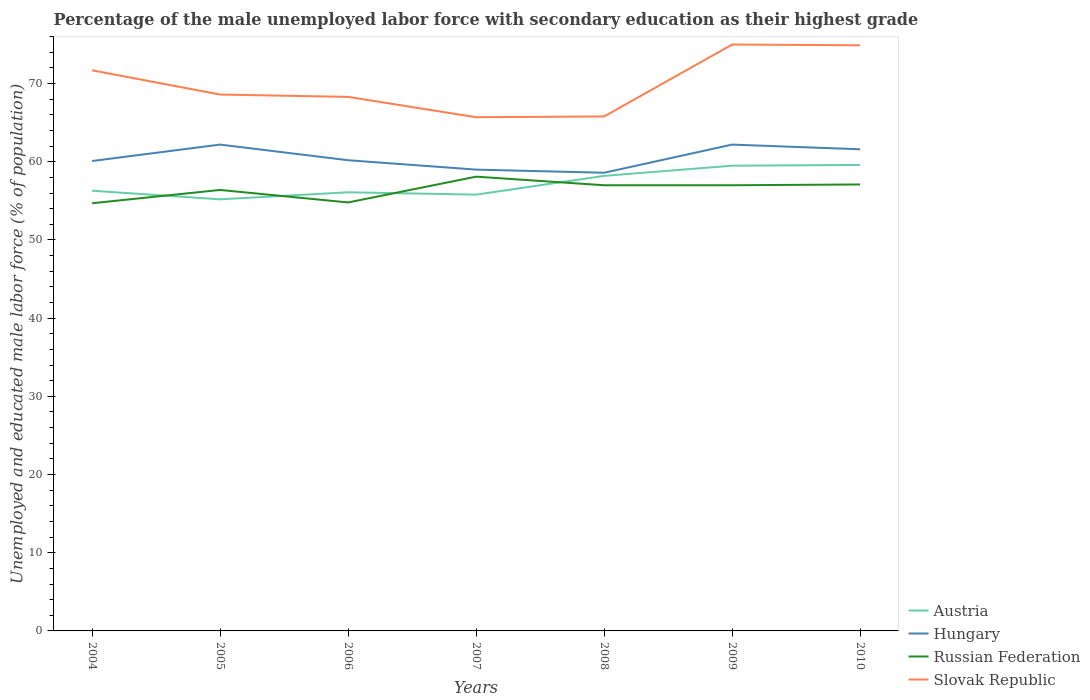Is the number of lines equal to the number of legend labels?
Give a very brief answer. Yes. Across all years, what is the maximum percentage of the unemployed male labor force with secondary education in Russian Federation?
Offer a terse response. 54.7. In which year was the percentage of the unemployed male labor force with secondary education in Hungary maximum?
Your answer should be compact. 2008. What is the total percentage of the unemployed male labor force with secondary education in Russian Federation in the graph?
Provide a succinct answer. -2.3. What is the difference between the highest and the second highest percentage of the unemployed male labor force with secondary education in Hungary?
Keep it short and to the point. 3.6. What is the difference between the highest and the lowest percentage of the unemployed male labor force with secondary education in Hungary?
Make the answer very short. 3. Is the percentage of the unemployed male labor force with secondary education in Slovak Republic strictly greater than the percentage of the unemployed male labor force with secondary education in Russian Federation over the years?
Your answer should be very brief. No. What is the difference between two consecutive major ticks on the Y-axis?
Make the answer very short. 10. Are the values on the major ticks of Y-axis written in scientific E-notation?
Ensure brevity in your answer.  No. Does the graph contain grids?
Give a very brief answer. No. How many legend labels are there?
Give a very brief answer. 4. What is the title of the graph?
Your response must be concise. Percentage of the male unemployed labor force with secondary education as their highest grade. What is the label or title of the Y-axis?
Make the answer very short. Unemployed and educated male labor force (% of population). What is the Unemployed and educated male labor force (% of population) of Austria in 2004?
Provide a short and direct response. 56.3. What is the Unemployed and educated male labor force (% of population) of Hungary in 2004?
Ensure brevity in your answer.  60.1. What is the Unemployed and educated male labor force (% of population) in Russian Federation in 2004?
Your answer should be compact. 54.7. What is the Unemployed and educated male labor force (% of population) of Slovak Republic in 2004?
Offer a very short reply. 71.7. What is the Unemployed and educated male labor force (% of population) of Austria in 2005?
Give a very brief answer. 55.2. What is the Unemployed and educated male labor force (% of population) of Hungary in 2005?
Offer a very short reply. 62.2. What is the Unemployed and educated male labor force (% of population) in Russian Federation in 2005?
Make the answer very short. 56.4. What is the Unemployed and educated male labor force (% of population) in Slovak Republic in 2005?
Give a very brief answer. 68.6. What is the Unemployed and educated male labor force (% of population) of Austria in 2006?
Offer a very short reply. 56.1. What is the Unemployed and educated male labor force (% of population) in Hungary in 2006?
Offer a very short reply. 60.2. What is the Unemployed and educated male labor force (% of population) in Russian Federation in 2006?
Your answer should be very brief. 54.8. What is the Unemployed and educated male labor force (% of population) in Slovak Republic in 2006?
Provide a short and direct response. 68.3. What is the Unemployed and educated male labor force (% of population) of Austria in 2007?
Provide a succinct answer. 55.8. What is the Unemployed and educated male labor force (% of population) in Hungary in 2007?
Make the answer very short. 59. What is the Unemployed and educated male labor force (% of population) in Russian Federation in 2007?
Offer a terse response. 58.1. What is the Unemployed and educated male labor force (% of population) in Slovak Republic in 2007?
Provide a short and direct response. 65.7. What is the Unemployed and educated male labor force (% of population) in Austria in 2008?
Your response must be concise. 58.2. What is the Unemployed and educated male labor force (% of population) of Hungary in 2008?
Provide a short and direct response. 58.6. What is the Unemployed and educated male labor force (% of population) of Russian Federation in 2008?
Ensure brevity in your answer.  57. What is the Unemployed and educated male labor force (% of population) in Slovak Republic in 2008?
Your response must be concise. 65.8. What is the Unemployed and educated male labor force (% of population) of Austria in 2009?
Offer a very short reply. 59.5. What is the Unemployed and educated male labor force (% of population) in Hungary in 2009?
Keep it short and to the point. 62.2. What is the Unemployed and educated male labor force (% of population) of Russian Federation in 2009?
Provide a short and direct response. 57. What is the Unemployed and educated male labor force (% of population) in Austria in 2010?
Make the answer very short. 59.6. What is the Unemployed and educated male labor force (% of population) of Hungary in 2010?
Your answer should be compact. 61.6. What is the Unemployed and educated male labor force (% of population) of Russian Federation in 2010?
Offer a very short reply. 57.1. What is the Unemployed and educated male labor force (% of population) of Slovak Republic in 2010?
Provide a succinct answer. 74.9. Across all years, what is the maximum Unemployed and educated male labor force (% of population) of Austria?
Your answer should be very brief. 59.6. Across all years, what is the maximum Unemployed and educated male labor force (% of population) in Hungary?
Give a very brief answer. 62.2. Across all years, what is the maximum Unemployed and educated male labor force (% of population) of Russian Federation?
Your answer should be very brief. 58.1. Across all years, what is the maximum Unemployed and educated male labor force (% of population) in Slovak Republic?
Make the answer very short. 75. Across all years, what is the minimum Unemployed and educated male labor force (% of population) in Austria?
Your response must be concise. 55.2. Across all years, what is the minimum Unemployed and educated male labor force (% of population) of Hungary?
Offer a very short reply. 58.6. Across all years, what is the minimum Unemployed and educated male labor force (% of population) in Russian Federation?
Keep it short and to the point. 54.7. Across all years, what is the minimum Unemployed and educated male labor force (% of population) of Slovak Republic?
Make the answer very short. 65.7. What is the total Unemployed and educated male labor force (% of population) of Austria in the graph?
Offer a very short reply. 400.7. What is the total Unemployed and educated male labor force (% of population) in Hungary in the graph?
Your answer should be very brief. 423.9. What is the total Unemployed and educated male labor force (% of population) of Russian Federation in the graph?
Provide a succinct answer. 395.1. What is the total Unemployed and educated male labor force (% of population) of Slovak Republic in the graph?
Offer a very short reply. 490. What is the difference between the Unemployed and educated male labor force (% of population) in Austria in 2004 and that in 2005?
Offer a terse response. 1.1. What is the difference between the Unemployed and educated male labor force (% of population) in Russian Federation in 2004 and that in 2005?
Your response must be concise. -1.7. What is the difference between the Unemployed and educated male labor force (% of population) in Russian Federation in 2004 and that in 2006?
Keep it short and to the point. -0.1. What is the difference between the Unemployed and educated male labor force (% of population) in Austria in 2004 and that in 2007?
Ensure brevity in your answer.  0.5. What is the difference between the Unemployed and educated male labor force (% of population) in Hungary in 2004 and that in 2007?
Keep it short and to the point. 1.1. What is the difference between the Unemployed and educated male labor force (% of population) in Russian Federation in 2004 and that in 2007?
Give a very brief answer. -3.4. What is the difference between the Unemployed and educated male labor force (% of population) in Slovak Republic in 2004 and that in 2007?
Provide a succinct answer. 6. What is the difference between the Unemployed and educated male labor force (% of population) in Slovak Republic in 2004 and that in 2008?
Offer a terse response. 5.9. What is the difference between the Unemployed and educated male labor force (% of population) in Austria in 2004 and that in 2009?
Keep it short and to the point. -3.2. What is the difference between the Unemployed and educated male labor force (% of population) in Hungary in 2004 and that in 2009?
Offer a terse response. -2.1. What is the difference between the Unemployed and educated male labor force (% of population) of Slovak Republic in 2004 and that in 2009?
Your answer should be very brief. -3.3. What is the difference between the Unemployed and educated male labor force (% of population) in Austria in 2004 and that in 2010?
Make the answer very short. -3.3. What is the difference between the Unemployed and educated male labor force (% of population) in Hungary in 2004 and that in 2010?
Provide a short and direct response. -1.5. What is the difference between the Unemployed and educated male labor force (% of population) of Russian Federation in 2004 and that in 2010?
Ensure brevity in your answer.  -2.4. What is the difference between the Unemployed and educated male labor force (% of population) in Slovak Republic in 2004 and that in 2010?
Ensure brevity in your answer.  -3.2. What is the difference between the Unemployed and educated male labor force (% of population) in Hungary in 2005 and that in 2006?
Your answer should be very brief. 2. What is the difference between the Unemployed and educated male labor force (% of population) in Slovak Republic in 2005 and that in 2006?
Give a very brief answer. 0.3. What is the difference between the Unemployed and educated male labor force (% of population) in Hungary in 2005 and that in 2007?
Your response must be concise. 3.2. What is the difference between the Unemployed and educated male labor force (% of population) of Russian Federation in 2005 and that in 2007?
Ensure brevity in your answer.  -1.7. What is the difference between the Unemployed and educated male labor force (% of population) in Slovak Republic in 2005 and that in 2007?
Provide a succinct answer. 2.9. What is the difference between the Unemployed and educated male labor force (% of population) of Russian Federation in 2005 and that in 2008?
Keep it short and to the point. -0.6. What is the difference between the Unemployed and educated male labor force (% of population) in Slovak Republic in 2005 and that in 2008?
Your answer should be very brief. 2.8. What is the difference between the Unemployed and educated male labor force (% of population) in Russian Federation in 2005 and that in 2009?
Offer a very short reply. -0.6. What is the difference between the Unemployed and educated male labor force (% of population) in Austria in 2005 and that in 2010?
Your answer should be very brief. -4.4. What is the difference between the Unemployed and educated male labor force (% of population) in Hungary in 2005 and that in 2010?
Provide a short and direct response. 0.6. What is the difference between the Unemployed and educated male labor force (% of population) of Slovak Republic in 2005 and that in 2010?
Give a very brief answer. -6.3. What is the difference between the Unemployed and educated male labor force (% of population) in Hungary in 2006 and that in 2007?
Your response must be concise. 1.2. What is the difference between the Unemployed and educated male labor force (% of population) in Slovak Republic in 2006 and that in 2007?
Ensure brevity in your answer.  2.6. What is the difference between the Unemployed and educated male labor force (% of population) of Hungary in 2006 and that in 2008?
Your response must be concise. 1.6. What is the difference between the Unemployed and educated male labor force (% of population) of Austria in 2006 and that in 2009?
Ensure brevity in your answer.  -3.4. What is the difference between the Unemployed and educated male labor force (% of population) of Russian Federation in 2006 and that in 2009?
Your answer should be compact. -2.2. What is the difference between the Unemployed and educated male labor force (% of population) of Slovak Republic in 2006 and that in 2009?
Make the answer very short. -6.7. What is the difference between the Unemployed and educated male labor force (% of population) in Slovak Republic in 2006 and that in 2010?
Offer a terse response. -6.6. What is the difference between the Unemployed and educated male labor force (% of population) in Austria in 2007 and that in 2008?
Offer a very short reply. -2.4. What is the difference between the Unemployed and educated male labor force (% of population) in Hungary in 2007 and that in 2008?
Offer a terse response. 0.4. What is the difference between the Unemployed and educated male labor force (% of population) in Slovak Republic in 2007 and that in 2008?
Provide a short and direct response. -0.1. What is the difference between the Unemployed and educated male labor force (% of population) of Austria in 2007 and that in 2009?
Make the answer very short. -3.7. What is the difference between the Unemployed and educated male labor force (% of population) of Hungary in 2007 and that in 2009?
Your answer should be very brief. -3.2. What is the difference between the Unemployed and educated male labor force (% of population) in Slovak Republic in 2007 and that in 2009?
Give a very brief answer. -9.3. What is the difference between the Unemployed and educated male labor force (% of population) of Russian Federation in 2007 and that in 2010?
Provide a short and direct response. 1. What is the difference between the Unemployed and educated male labor force (% of population) in Slovak Republic in 2007 and that in 2010?
Your response must be concise. -9.2. What is the difference between the Unemployed and educated male labor force (% of population) of Austria in 2008 and that in 2009?
Your response must be concise. -1.3. What is the difference between the Unemployed and educated male labor force (% of population) of Hungary in 2008 and that in 2009?
Make the answer very short. -3.6. What is the difference between the Unemployed and educated male labor force (% of population) in Austria in 2008 and that in 2010?
Your response must be concise. -1.4. What is the difference between the Unemployed and educated male labor force (% of population) of Russian Federation in 2008 and that in 2010?
Your answer should be very brief. -0.1. What is the difference between the Unemployed and educated male labor force (% of population) of Austria in 2009 and that in 2010?
Provide a short and direct response. -0.1. What is the difference between the Unemployed and educated male labor force (% of population) of Hungary in 2009 and that in 2010?
Ensure brevity in your answer.  0.6. What is the difference between the Unemployed and educated male labor force (% of population) in Slovak Republic in 2009 and that in 2010?
Keep it short and to the point. 0.1. What is the difference between the Unemployed and educated male labor force (% of population) of Hungary in 2004 and the Unemployed and educated male labor force (% of population) of Slovak Republic in 2005?
Offer a very short reply. -8.5. What is the difference between the Unemployed and educated male labor force (% of population) in Russian Federation in 2004 and the Unemployed and educated male labor force (% of population) in Slovak Republic in 2005?
Your answer should be very brief. -13.9. What is the difference between the Unemployed and educated male labor force (% of population) of Austria in 2004 and the Unemployed and educated male labor force (% of population) of Russian Federation in 2006?
Your answer should be very brief. 1.5. What is the difference between the Unemployed and educated male labor force (% of population) in Austria in 2004 and the Unemployed and educated male labor force (% of population) in Slovak Republic in 2006?
Make the answer very short. -12. What is the difference between the Unemployed and educated male labor force (% of population) of Hungary in 2004 and the Unemployed and educated male labor force (% of population) of Russian Federation in 2006?
Your answer should be very brief. 5.3. What is the difference between the Unemployed and educated male labor force (% of population) in Hungary in 2004 and the Unemployed and educated male labor force (% of population) in Slovak Republic in 2006?
Offer a very short reply. -8.2. What is the difference between the Unemployed and educated male labor force (% of population) of Austria in 2004 and the Unemployed and educated male labor force (% of population) of Hungary in 2007?
Your answer should be very brief. -2.7. What is the difference between the Unemployed and educated male labor force (% of population) in Austria in 2004 and the Unemployed and educated male labor force (% of population) in Russian Federation in 2007?
Offer a very short reply. -1.8. What is the difference between the Unemployed and educated male labor force (% of population) in Hungary in 2004 and the Unemployed and educated male labor force (% of population) in Slovak Republic in 2007?
Provide a short and direct response. -5.6. What is the difference between the Unemployed and educated male labor force (% of population) in Russian Federation in 2004 and the Unemployed and educated male labor force (% of population) in Slovak Republic in 2007?
Your response must be concise. -11. What is the difference between the Unemployed and educated male labor force (% of population) of Hungary in 2004 and the Unemployed and educated male labor force (% of population) of Russian Federation in 2008?
Ensure brevity in your answer.  3.1. What is the difference between the Unemployed and educated male labor force (% of population) in Hungary in 2004 and the Unemployed and educated male labor force (% of population) in Slovak Republic in 2008?
Keep it short and to the point. -5.7. What is the difference between the Unemployed and educated male labor force (% of population) of Austria in 2004 and the Unemployed and educated male labor force (% of population) of Russian Federation in 2009?
Offer a terse response. -0.7. What is the difference between the Unemployed and educated male labor force (% of population) of Austria in 2004 and the Unemployed and educated male labor force (% of population) of Slovak Republic in 2009?
Provide a succinct answer. -18.7. What is the difference between the Unemployed and educated male labor force (% of population) of Hungary in 2004 and the Unemployed and educated male labor force (% of population) of Russian Federation in 2009?
Keep it short and to the point. 3.1. What is the difference between the Unemployed and educated male labor force (% of population) of Hungary in 2004 and the Unemployed and educated male labor force (% of population) of Slovak Republic in 2009?
Keep it short and to the point. -14.9. What is the difference between the Unemployed and educated male labor force (% of population) in Russian Federation in 2004 and the Unemployed and educated male labor force (% of population) in Slovak Republic in 2009?
Your answer should be compact. -20.3. What is the difference between the Unemployed and educated male labor force (% of population) in Austria in 2004 and the Unemployed and educated male labor force (% of population) in Russian Federation in 2010?
Your response must be concise. -0.8. What is the difference between the Unemployed and educated male labor force (% of population) of Austria in 2004 and the Unemployed and educated male labor force (% of population) of Slovak Republic in 2010?
Keep it short and to the point. -18.6. What is the difference between the Unemployed and educated male labor force (% of population) of Hungary in 2004 and the Unemployed and educated male labor force (% of population) of Russian Federation in 2010?
Provide a succinct answer. 3. What is the difference between the Unemployed and educated male labor force (% of population) in Hungary in 2004 and the Unemployed and educated male labor force (% of population) in Slovak Republic in 2010?
Keep it short and to the point. -14.8. What is the difference between the Unemployed and educated male labor force (% of population) in Russian Federation in 2004 and the Unemployed and educated male labor force (% of population) in Slovak Republic in 2010?
Your response must be concise. -20.2. What is the difference between the Unemployed and educated male labor force (% of population) in Austria in 2005 and the Unemployed and educated male labor force (% of population) in Russian Federation in 2006?
Give a very brief answer. 0.4. What is the difference between the Unemployed and educated male labor force (% of population) of Austria in 2005 and the Unemployed and educated male labor force (% of population) of Slovak Republic in 2006?
Offer a very short reply. -13.1. What is the difference between the Unemployed and educated male labor force (% of population) in Hungary in 2005 and the Unemployed and educated male labor force (% of population) in Russian Federation in 2006?
Provide a succinct answer. 7.4. What is the difference between the Unemployed and educated male labor force (% of population) of Russian Federation in 2005 and the Unemployed and educated male labor force (% of population) of Slovak Republic in 2006?
Your response must be concise. -11.9. What is the difference between the Unemployed and educated male labor force (% of population) in Austria in 2005 and the Unemployed and educated male labor force (% of population) in Hungary in 2007?
Provide a short and direct response. -3.8. What is the difference between the Unemployed and educated male labor force (% of population) of Austria in 2005 and the Unemployed and educated male labor force (% of population) of Russian Federation in 2007?
Keep it short and to the point. -2.9. What is the difference between the Unemployed and educated male labor force (% of population) in Austria in 2005 and the Unemployed and educated male labor force (% of population) in Slovak Republic in 2007?
Give a very brief answer. -10.5. What is the difference between the Unemployed and educated male labor force (% of population) of Hungary in 2005 and the Unemployed and educated male labor force (% of population) of Russian Federation in 2007?
Provide a short and direct response. 4.1. What is the difference between the Unemployed and educated male labor force (% of population) of Hungary in 2005 and the Unemployed and educated male labor force (% of population) of Slovak Republic in 2007?
Your response must be concise. -3.5. What is the difference between the Unemployed and educated male labor force (% of population) of Russian Federation in 2005 and the Unemployed and educated male labor force (% of population) of Slovak Republic in 2007?
Your answer should be compact. -9.3. What is the difference between the Unemployed and educated male labor force (% of population) in Austria in 2005 and the Unemployed and educated male labor force (% of population) in Hungary in 2008?
Ensure brevity in your answer.  -3.4. What is the difference between the Unemployed and educated male labor force (% of population) of Austria in 2005 and the Unemployed and educated male labor force (% of population) of Slovak Republic in 2008?
Make the answer very short. -10.6. What is the difference between the Unemployed and educated male labor force (% of population) of Hungary in 2005 and the Unemployed and educated male labor force (% of population) of Slovak Republic in 2008?
Your answer should be compact. -3.6. What is the difference between the Unemployed and educated male labor force (% of population) in Austria in 2005 and the Unemployed and educated male labor force (% of population) in Hungary in 2009?
Keep it short and to the point. -7. What is the difference between the Unemployed and educated male labor force (% of population) of Austria in 2005 and the Unemployed and educated male labor force (% of population) of Slovak Republic in 2009?
Your response must be concise. -19.8. What is the difference between the Unemployed and educated male labor force (% of population) of Russian Federation in 2005 and the Unemployed and educated male labor force (% of population) of Slovak Republic in 2009?
Your response must be concise. -18.6. What is the difference between the Unemployed and educated male labor force (% of population) of Austria in 2005 and the Unemployed and educated male labor force (% of population) of Hungary in 2010?
Ensure brevity in your answer.  -6.4. What is the difference between the Unemployed and educated male labor force (% of population) in Austria in 2005 and the Unemployed and educated male labor force (% of population) in Russian Federation in 2010?
Make the answer very short. -1.9. What is the difference between the Unemployed and educated male labor force (% of population) in Austria in 2005 and the Unemployed and educated male labor force (% of population) in Slovak Republic in 2010?
Keep it short and to the point. -19.7. What is the difference between the Unemployed and educated male labor force (% of population) of Hungary in 2005 and the Unemployed and educated male labor force (% of population) of Russian Federation in 2010?
Ensure brevity in your answer.  5.1. What is the difference between the Unemployed and educated male labor force (% of population) in Hungary in 2005 and the Unemployed and educated male labor force (% of population) in Slovak Republic in 2010?
Provide a succinct answer. -12.7. What is the difference between the Unemployed and educated male labor force (% of population) in Russian Federation in 2005 and the Unemployed and educated male labor force (% of population) in Slovak Republic in 2010?
Provide a succinct answer. -18.5. What is the difference between the Unemployed and educated male labor force (% of population) of Hungary in 2006 and the Unemployed and educated male labor force (% of population) of Russian Federation in 2007?
Your answer should be very brief. 2.1. What is the difference between the Unemployed and educated male labor force (% of population) of Hungary in 2006 and the Unemployed and educated male labor force (% of population) of Slovak Republic in 2007?
Your answer should be very brief. -5.5. What is the difference between the Unemployed and educated male labor force (% of population) in Austria in 2006 and the Unemployed and educated male labor force (% of population) in Hungary in 2008?
Give a very brief answer. -2.5. What is the difference between the Unemployed and educated male labor force (% of population) in Austria in 2006 and the Unemployed and educated male labor force (% of population) in Slovak Republic in 2008?
Make the answer very short. -9.7. What is the difference between the Unemployed and educated male labor force (% of population) in Austria in 2006 and the Unemployed and educated male labor force (% of population) in Slovak Republic in 2009?
Offer a very short reply. -18.9. What is the difference between the Unemployed and educated male labor force (% of population) in Hungary in 2006 and the Unemployed and educated male labor force (% of population) in Russian Federation in 2009?
Make the answer very short. 3.2. What is the difference between the Unemployed and educated male labor force (% of population) of Hungary in 2006 and the Unemployed and educated male labor force (% of population) of Slovak Republic in 2009?
Your answer should be compact. -14.8. What is the difference between the Unemployed and educated male labor force (% of population) of Russian Federation in 2006 and the Unemployed and educated male labor force (% of population) of Slovak Republic in 2009?
Provide a succinct answer. -20.2. What is the difference between the Unemployed and educated male labor force (% of population) in Austria in 2006 and the Unemployed and educated male labor force (% of population) in Slovak Republic in 2010?
Your answer should be very brief. -18.8. What is the difference between the Unemployed and educated male labor force (% of population) in Hungary in 2006 and the Unemployed and educated male labor force (% of population) in Russian Federation in 2010?
Provide a short and direct response. 3.1. What is the difference between the Unemployed and educated male labor force (% of population) in Hungary in 2006 and the Unemployed and educated male labor force (% of population) in Slovak Republic in 2010?
Provide a short and direct response. -14.7. What is the difference between the Unemployed and educated male labor force (% of population) of Russian Federation in 2006 and the Unemployed and educated male labor force (% of population) of Slovak Republic in 2010?
Your answer should be very brief. -20.1. What is the difference between the Unemployed and educated male labor force (% of population) in Austria in 2007 and the Unemployed and educated male labor force (% of population) in Russian Federation in 2008?
Make the answer very short. -1.2. What is the difference between the Unemployed and educated male labor force (% of population) in Austria in 2007 and the Unemployed and educated male labor force (% of population) in Slovak Republic in 2008?
Your answer should be very brief. -10. What is the difference between the Unemployed and educated male labor force (% of population) of Hungary in 2007 and the Unemployed and educated male labor force (% of population) of Russian Federation in 2008?
Ensure brevity in your answer.  2. What is the difference between the Unemployed and educated male labor force (% of population) in Russian Federation in 2007 and the Unemployed and educated male labor force (% of population) in Slovak Republic in 2008?
Ensure brevity in your answer.  -7.7. What is the difference between the Unemployed and educated male labor force (% of population) of Austria in 2007 and the Unemployed and educated male labor force (% of population) of Hungary in 2009?
Offer a very short reply. -6.4. What is the difference between the Unemployed and educated male labor force (% of population) in Austria in 2007 and the Unemployed and educated male labor force (% of population) in Russian Federation in 2009?
Offer a terse response. -1.2. What is the difference between the Unemployed and educated male labor force (% of population) in Austria in 2007 and the Unemployed and educated male labor force (% of population) in Slovak Republic in 2009?
Make the answer very short. -19.2. What is the difference between the Unemployed and educated male labor force (% of population) in Hungary in 2007 and the Unemployed and educated male labor force (% of population) in Russian Federation in 2009?
Provide a succinct answer. 2. What is the difference between the Unemployed and educated male labor force (% of population) of Russian Federation in 2007 and the Unemployed and educated male labor force (% of population) of Slovak Republic in 2009?
Offer a very short reply. -16.9. What is the difference between the Unemployed and educated male labor force (% of population) in Austria in 2007 and the Unemployed and educated male labor force (% of population) in Slovak Republic in 2010?
Offer a terse response. -19.1. What is the difference between the Unemployed and educated male labor force (% of population) in Hungary in 2007 and the Unemployed and educated male labor force (% of population) in Slovak Republic in 2010?
Keep it short and to the point. -15.9. What is the difference between the Unemployed and educated male labor force (% of population) in Russian Federation in 2007 and the Unemployed and educated male labor force (% of population) in Slovak Republic in 2010?
Your answer should be compact. -16.8. What is the difference between the Unemployed and educated male labor force (% of population) of Austria in 2008 and the Unemployed and educated male labor force (% of population) of Hungary in 2009?
Make the answer very short. -4. What is the difference between the Unemployed and educated male labor force (% of population) in Austria in 2008 and the Unemployed and educated male labor force (% of population) in Russian Federation in 2009?
Offer a very short reply. 1.2. What is the difference between the Unemployed and educated male labor force (% of population) of Austria in 2008 and the Unemployed and educated male labor force (% of population) of Slovak Republic in 2009?
Ensure brevity in your answer.  -16.8. What is the difference between the Unemployed and educated male labor force (% of population) of Hungary in 2008 and the Unemployed and educated male labor force (% of population) of Russian Federation in 2009?
Provide a succinct answer. 1.6. What is the difference between the Unemployed and educated male labor force (% of population) in Hungary in 2008 and the Unemployed and educated male labor force (% of population) in Slovak Republic in 2009?
Your response must be concise. -16.4. What is the difference between the Unemployed and educated male labor force (% of population) of Russian Federation in 2008 and the Unemployed and educated male labor force (% of population) of Slovak Republic in 2009?
Your response must be concise. -18. What is the difference between the Unemployed and educated male labor force (% of population) in Austria in 2008 and the Unemployed and educated male labor force (% of population) in Russian Federation in 2010?
Keep it short and to the point. 1.1. What is the difference between the Unemployed and educated male labor force (% of population) in Austria in 2008 and the Unemployed and educated male labor force (% of population) in Slovak Republic in 2010?
Your response must be concise. -16.7. What is the difference between the Unemployed and educated male labor force (% of population) of Hungary in 2008 and the Unemployed and educated male labor force (% of population) of Russian Federation in 2010?
Your response must be concise. 1.5. What is the difference between the Unemployed and educated male labor force (% of population) of Hungary in 2008 and the Unemployed and educated male labor force (% of population) of Slovak Republic in 2010?
Keep it short and to the point. -16.3. What is the difference between the Unemployed and educated male labor force (% of population) in Russian Federation in 2008 and the Unemployed and educated male labor force (% of population) in Slovak Republic in 2010?
Offer a terse response. -17.9. What is the difference between the Unemployed and educated male labor force (% of population) of Austria in 2009 and the Unemployed and educated male labor force (% of population) of Russian Federation in 2010?
Your response must be concise. 2.4. What is the difference between the Unemployed and educated male labor force (% of population) in Austria in 2009 and the Unemployed and educated male labor force (% of population) in Slovak Republic in 2010?
Make the answer very short. -15.4. What is the difference between the Unemployed and educated male labor force (% of population) in Hungary in 2009 and the Unemployed and educated male labor force (% of population) in Slovak Republic in 2010?
Your answer should be compact. -12.7. What is the difference between the Unemployed and educated male labor force (% of population) in Russian Federation in 2009 and the Unemployed and educated male labor force (% of population) in Slovak Republic in 2010?
Make the answer very short. -17.9. What is the average Unemployed and educated male labor force (% of population) in Austria per year?
Give a very brief answer. 57.24. What is the average Unemployed and educated male labor force (% of population) of Hungary per year?
Offer a terse response. 60.56. What is the average Unemployed and educated male labor force (% of population) in Russian Federation per year?
Offer a terse response. 56.44. What is the average Unemployed and educated male labor force (% of population) in Slovak Republic per year?
Provide a short and direct response. 70. In the year 2004, what is the difference between the Unemployed and educated male labor force (% of population) of Austria and Unemployed and educated male labor force (% of population) of Slovak Republic?
Provide a short and direct response. -15.4. In the year 2004, what is the difference between the Unemployed and educated male labor force (% of population) of Hungary and Unemployed and educated male labor force (% of population) of Russian Federation?
Ensure brevity in your answer.  5.4. In the year 2004, what is the difference between the Unemployed and educated male labor force (% of population) in Hungary and Unemployed and educated male labor force (% of population) in Slovak Republic?
Provide a succinct answer. -11.6. In the year 2004, what is the difference between the Unemployed and educated male labor force (% of population) in Russian Federation and Unemployed and educated male labor force (% of population) in Slovak Republic?
Give a very brief answer. -17. In the year 2005, what is the difference between the Unemployed and educated male labor force (% of population) of Austria and Unemployed and educated male labor force (% of population) of Russian Federation?
Keep it short and to the point. -1.2. In the year 2005, what is the difference between the Unemployed and educated male labor force (% of population) in Austria and Unemployed and educated male labor force (% of population) in Slovak Republic?
Provide a short and direct response. -13.4. In the year 2005, what is the difference between the Unemployed and educated male labor force (% of population) of Hungary and Unemployed and educated male labor force (% of population) of Slovak Republic?
Your answer should be compact. -6.4. In the year 2005, what is the difference between the Unemployed and educated male labor force (% of population) in Russian Federation and Unemployed and educated male labor force (% of population) in Slovak Republic?
Offer a terse response. -12.2. In the year 2006, what is the difference between the Unemployed and educated male labor force (% of population) in Austria and Unemployed and educated male labor force (% of population) in Hungary?
Provide a short and direct response. -4.1. In the year 2006, what is the difference between the Unemployed and educated male labor force (% of population) in Austria and Unemployed and educated male labor force (% of population) in Slovak Republic?
Ensure brevity in your answer.  -12.2. In the year 2007, what is the difference between the Unemployed and educated male labor force (% of population) in Austria and Unemployed and educated male labor force (% of population) in Hungary?
Your answer should be very brief. -3.2. In the year 2007, what is the difference between the Unemployed and educated male labor force (% of population) of Hungary and Unemployed and educated male labor force (% of population) of Russian Federation?
Your response must be concise. 0.9. In the year 2007, what is the difference between the Unemployed and educated male labor force (% of population) of Hungary and Unemployed and educated male labor force (% of population) of Slovak Republic?
Offer a very short reply. -6.7. In the year 2008, what is the difference between the Unemployed and educated male labor force (% of population) in Austria and Unemployed and educated male labor force (% of population) in Slovak Republic?
Provide a short and direct response. -7.6. In the year 2008, what is the difference between the Unemployed and educated male labor force (% of population) of Hungary and Unemployed and educated male labor force (% of population) of Russian Federation?
Your response must be concise. 1.6. In the year 2008, what is the difference between the Unemployed and educated male labor force (% of population) in Russian Federation and Unemployed and educated male labor force (% of population) in Slovak Republic?
Your answer should be very brief. -8.8. In the year 2009, what is the difference between the Unemployed and educated male labor force (% of population) of Austria and Unemployed and educated male labor force (% of population) of Russian Federation?
Provide a succinct answer. 2.5. In the year 2009, what is the difference between the Unemployed and educated male labor force (% of population) of Austria and Unemployed and educated male labor force (% of population) of Slovak Republic?
Your response must be concise. -15.5. In the year 2009, what is the difference between the Unemployed and educated male labor force (% of population) in Hungary and Unemployed and educated male labor force (% of population) in Russian Federation?
Your answer should be compact. 5.2. In the year 2009, what is the difference between the Unemployed and educated male labor force (% of population) of Russian Federation and Unemployed and educated male labor force (% of population) of Slovak Republic?
Offer a very short reply. -18. In the year 2010, what is the difference between the Unemployed and educated male labor force (% of population) in Austria and Unemployed and educated male labor force (% of population) in Hungary?
Keep it short and to the point. -2. In the year 2010, what is the difference between the Unemployed and educated male labor force (% of population) in Austria and Unemployed and educated male labor force (% of population) in Slovak Republic?
Your answer should be compact. -15.3. In the year 2010, what is the difference between the Unemployed and educated male labor force (% of population) of Hungary and Unemployed and educated male labor force (% of population) of Slovak Republic?
Your response must be concise. -13.3. In the year 2010, what is the difference between the Unemployed and educated male labor force (% of population) of Russian Federation and Unemployed and educated male labor force (% of population) of Slovak Republic?
Give a very brief answer. -17.8. What is the ratio of the Unemployed and educated male labor force (% of population) of Austria in 2004 to that in 2005?
Keep it short and to the point. 1.02. What is the ratio of the Unemployed and educated male labor force (% of population) in Hungary in 2004 to that in 2005?
Your answer should be compact. 0.97. What is the ratio of the Unemployed and educated male labor force (% of population) in Russian Federation in 2004 to that in 2005?
Provide a short and direct response. 0.97. What is the ratio of the Unemployed and educated male labor force (% of population) in Slovak Republic in 2004 to that in 2005?
Your answer should be compact. 1.05. What is the ratio of the Unemployed and educated male labor force (% of population) in Hungary in 2004 to that in 2006?
Your answer should be very brief. 1. What is the ratio of the Unemployed and educated male labor force (% of population) of Russian Federation in 2004 to that in 2006?
Give a very brief answer. 1. What is the ratio of the Unemployed and educated male labor force (% of population) of Slovak Republic in 2004 to that in 2006?
Offer a very short reply. 1.05. What is the ratio of the Unemployed and educated male labor force (% of population) of Hungary in 2004 to that in 2007?
Provide a succinct answer. 1.02. What is the ratio of the Unemployed and educated male labor force (% of population) in Russian Federation in 2004 to that in 2007?
Offer a very short reply. 0.94. What is the ratio of the Unemployed and educated male labor force (% of population) of Slovak Republic in 2004 to that in 2007?
Provide a short and direct response. 1.09. What is the ratio of the Unemployed and educated male labor force (% of population) in Austria in 2004 to that in 2008?
Offer a very short reply. 0.97. What is the ratio of the Unemployed and educated male labor force (% of population) in Hungary in 2004 to that in 2008?
Your response must be concise. 1.03. What is the ratio of the Unemployed and educated male labor force (% of population) of Russian Federation in 2004 to that in 2008?
Your response must be concise. 0.96. What is the ratio of the Unemployed and educated male labor force (% of population) of Slovak Republic in 2004 to that in 2008?
Keep it short and to the point. 1.09. What is the ratio of the Unemployed and educated male labor force (% of population) in Austria in 2004 to that in 2009?
Make the answer very short. 0.95. What is the ratio of the Unemployed and educated male labor force (% of population) of Hungary in 2004 to that in 2009?
Ensure brevity in your answer.  0.97. What is the ratio of the Unemployed and educated male labor force (% of population) of Russian Federation in 2004 to that in 2009?
Provide a short and direct response. 0.96. What is the ratio of the Unemployed and educated male labor force (% of population) in Slovak Republic in 2004 to that in 2009?
Your response must be concise. 0.96. What is the ratio of the Unemployed and educated male labor force (% of population) of Austria in 2004 to that in 2010?
Your answer should be compact. 0.94. What is the ratio of the Unemployed and educated male labor force (% of population) of Hungary in 2004 to that in 2010?
Ensure brevity in your answer.  0.98. What is the ratio of the Unemployed and educated male labor force (% of population) in Russian Federation in 2004 to that in 2010?
Provide a short and direct response. 0.96. What is the ratio of the Unemployed and educated male labor force (% of population) in Slovak Republic in 2004 to that in 2010?
Keep it short and to the point. 0.96. What is the ratio of the Unemployed and educated male labor force (% of population) of Hungary in 2005 to that in 2006?
Give a very brief answer. 1.03. What is the ratio of the Unemployed and educated male labor force (% of population) of Russian Federation in 2005 to that in 2006?
Give a very brief answer. 1.03. What is the ratio of the Unemployed and educated male labor force (% of population) of Austria in 2005 to that in 2007?
Provide a succinct answer. 0.99. What is the ratio of the Unemployed and educated male labor force (% of population) of Hungary in 2005 to that in 2007?
Make the answer very short. 1.05. What is the ratio of the Unemployed and educated male labor force (% of population) in Russian Federation in 2005 to that in 2007?
Keep it short and to the point. 0.97. What is the ratio of the Unemployed and educated male labor force (% of population) in Slovak Republic in 2005 to that in 2007?
Give a very brief answer. 1.04. What is the ratio of the Unemployed and educated male labor force (% of population) in Austria in 2005 to that in 2008?
Your answer should be compact. 0.95. What is the ratio of the Unemployed and educated male labor force (% of population) in Hungary in 2005 to that in 2008?
Give a very brief answer. 1.06. What is the ratio of the Unemployed and educated male labor force (% of population) of Slovak Republic in 2005 to that in 2008?
Your response must be concise. 1.04. What is the ratio of the Unemployed and educated male labor force (% of population) in Austria in 2005 to that in 2009?
Your response must be concise. 0.93. What is the ratio of the Unemployed and educated male labor force (% of population) in Slovak Republic in 2005 to that in 2009?
Your answer should be very brief. 0.91. What is the ratio of the Unemployed and educated male labor force (% of population) in Austria in 2005 to that in 2010?
Provide a short and direct response. 0.93. What is the ratio of the Unemployed and educated male labor force (% of population) of Hungary in 2005 to that in 2010?
Keep it short and to the point. 1.01. What is the ratio of the Unemployed and educated male labor force (% of population) in Russian Federation in 2005 to that in 2010?
Give a very brief answer. 0.99. What is the ratio of the Unemployed and educated male labor force (% of population) in Slovak Republic in 2005 to that in 2010?
Your response must be concise. 0.92. What is the ratio of the Unemployed and educated male labor force (% of population) of Austria in 2006 to that in 2007?
Provide a short and direct response. 1.01. What is the ratio of the Unemployed and educated male labor force (% of population) in Hungary in 2006 to that in 2007?
Offer a terse response. 1.02. What is the ratio of the Unemployed and educated male labor force (% of population) of Russian Federation in 2006 to that in 2007?
Provide a succinct answer. 0.94. What is the ratio of the Unemployed and educated male labor force (% of population) in Slovak Republic in 2006 to that in 2007?
Make the answer very short. 1.04. What is the ratio of the Unemployed and educated male labor force (% of population) in Austria in 2006 to that in 2008?
Your response must be concise. 0.96. What is the ratio of the Unemployed and educated male labor force (% of population) in Hungary in 2006 to that in 2008?
Ensure brevity in your answer.  1.03. What is the ratio of the Unemployed and educated male labor force (% of population) of Russian Federation in 2006 to that in 2008?
Offer a very short reply. 0.96. What is the ratio of the Unemployed and educated male labor force (% of population) in Slovak Republic in 2006 to that in 2008?
Your answer should be very brief. 1.04. What is the ratio of the Unemployed and educated male labor force (% of population) of Austria in 2006 to that in 2009?
Make the answer very short. 0.94. What is the ratio of the Unemployed and educated male labor force (% of population) of Hungary in 2006 to that in 2009?
Provide a short and direct response. 0.97. What is the ratio of the Unemployed and educated male labor force (% of population) in Russian Federation in 2006 to that in 2009?
Ensure brevity in your answer.  0.96. What is the ratio of the Unemployed and educated male labor force (% of population) in Slovak Republic in 2006 to that in 2009?
Keep it short and to the point. 0.91. What is the ratio of the Unemployed and educated male labor force (% of population) of Austria in 2006 to that in 2010?
Your answer should be very brief. 0.94. What is the ratio of the Unemployed and educated male labor force (% of population) of Hungary in 2006 to that in 2010?
Ensure brevity in your answer.  0.98. What is the ratio of the Unemployed and educated male labor force (% of population) of Russian Federation in 2006 to that in 2010?
Keep it short and to the point. 0.96. What is the ratio of the Unemployed and educated male labor force (% of population) in Slovak Republic in 2006 to that in 2010?
Provide a short and direct response. 0.91. What is the ratio of the Unemployed and educated male labor force (% of population) of Austria in 2007 to that in 2008?
Your answer should be compact. 0.96. What is the ratio of the Unemployed and educated male labor force (% of population) in Hungary in 2007 to that in 2008?
Provide a short and direct response. 1.01. What is the ratio of the Unemployed and educated male labor force (% of population) in Russian Federation in 2007 to that in 2008?
Keep it short and to the point. 1.02. What is the ratio of the Unemployed and educated male labor force (% of population) in Austria in 2007 to that in 2009?
Offer a terse response. 0.94. What is the ratio of the Unemployed and educated male labor force (% of population) of Hungary in 2007 to that in 2009?
Make the answer very short. 0.95. What is the ratio of the Unemployed and educated male labor force (% of population) of Russian Federation in 2007 to that in 2009?
Keep it short and to the point. 1.02. What is the ratio of the Unemployed and educated male labor force (% of population) of Slovak Republic in 2007 to that in 2009?
Provide a short and direct response. 0.88. What is the ratio of the Unemployed and educated male labor force (% of population) in Austria in 2007 to that in 2010?
Provide a succinct answer. 0.94. What is the ratio of the Unemployed and educated male labor force (% of population) in Hungary in 2007 to that in 2010?
Give a very brief answer. 0.96. What is the ratio of the Unemployed and educated male labor force (% of population) in Russian Federation in 2007 to that in 2010?
Keep it short and to the point. 1.02. What is the ratio of the Unemployed and educated male labor force (% of population) in Slovak Republic in 2007 to that in 2010?
Offer a very short reply. 0.88. What is the ratio of the Unemployed and educated male labor force (% of population) in Austria in 2008 to that in 2009?
Provide a succinct answer. 0.98. What is the ratio of the Unemployed and educated male labor force (% of population) of Hungary in 2008 to that in 2009?
Your response must be concise. 0.94. What is the ratio of the Unemployed and educated male labor force (% of population) in Slovak Republic in 2008 to that in 2009?
Your answer should be very brief. 0.88. What is the ratio of the Unemployed and educated male labor force (% of population) of Austria in 2008 to that in 2010?
Offer a very short reply. 0.98. What is the ratio of the Unemployed and educated male labor force (% of population) of Hungary in 2008 to that in 2010?
Keep it short and to the point. 0.95. What is the ratio of the Unemployed and educated male labor force (% of population) in Russian Federation in 2008 to that in 2010?
Give a very brief answer. 1. What is the ratio of the Unemployed and educated male labor force (% of population) in Slovak Republic in 2008 to that in 2010?
Your answer should be very brief. 0.88. What is the ratio of the Unemployed and educated male labor force (% of population) in Hungary in 2009 to that in 2010?
Offer a very short reply. 1.01. What is the ratio of the Unemployed and educated male labor force (% of population) of Russian Federation in 2009 to that in 2010?
Provide a succinct answer. 1. What is the difference between the highest and the second highest Unemployed and educated male labor force (% of population) of Austria?
Your answer should be compact. 0.1. What is the difference between the highest and the second highest Unemployed and educated male labor force (% of population) of Russian Federation?
Your answer should be very brief. 1. What is the difference between the highest and the lowest Unemployed and educated male labor force (% of population) of Austria?
Your answer should be compact. 4.4. What is the difference between the highest and the lowest Unemployed and educated male labor force (% of population) of Hungary?
Provide a short and direct response. 3.6. What is the difference between the highest and the lowest Unemployed and educated male labor force (% of population) of Russian Federation?
Your answer should be very brief. 3.4. 